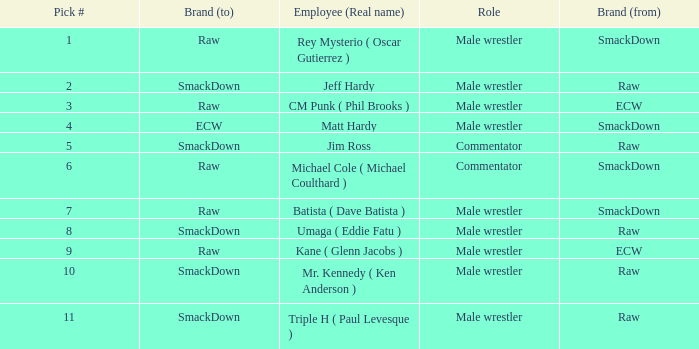What is the actual name of the male wrestler on raw with a selection number less than 6? Jeff Hardy. 